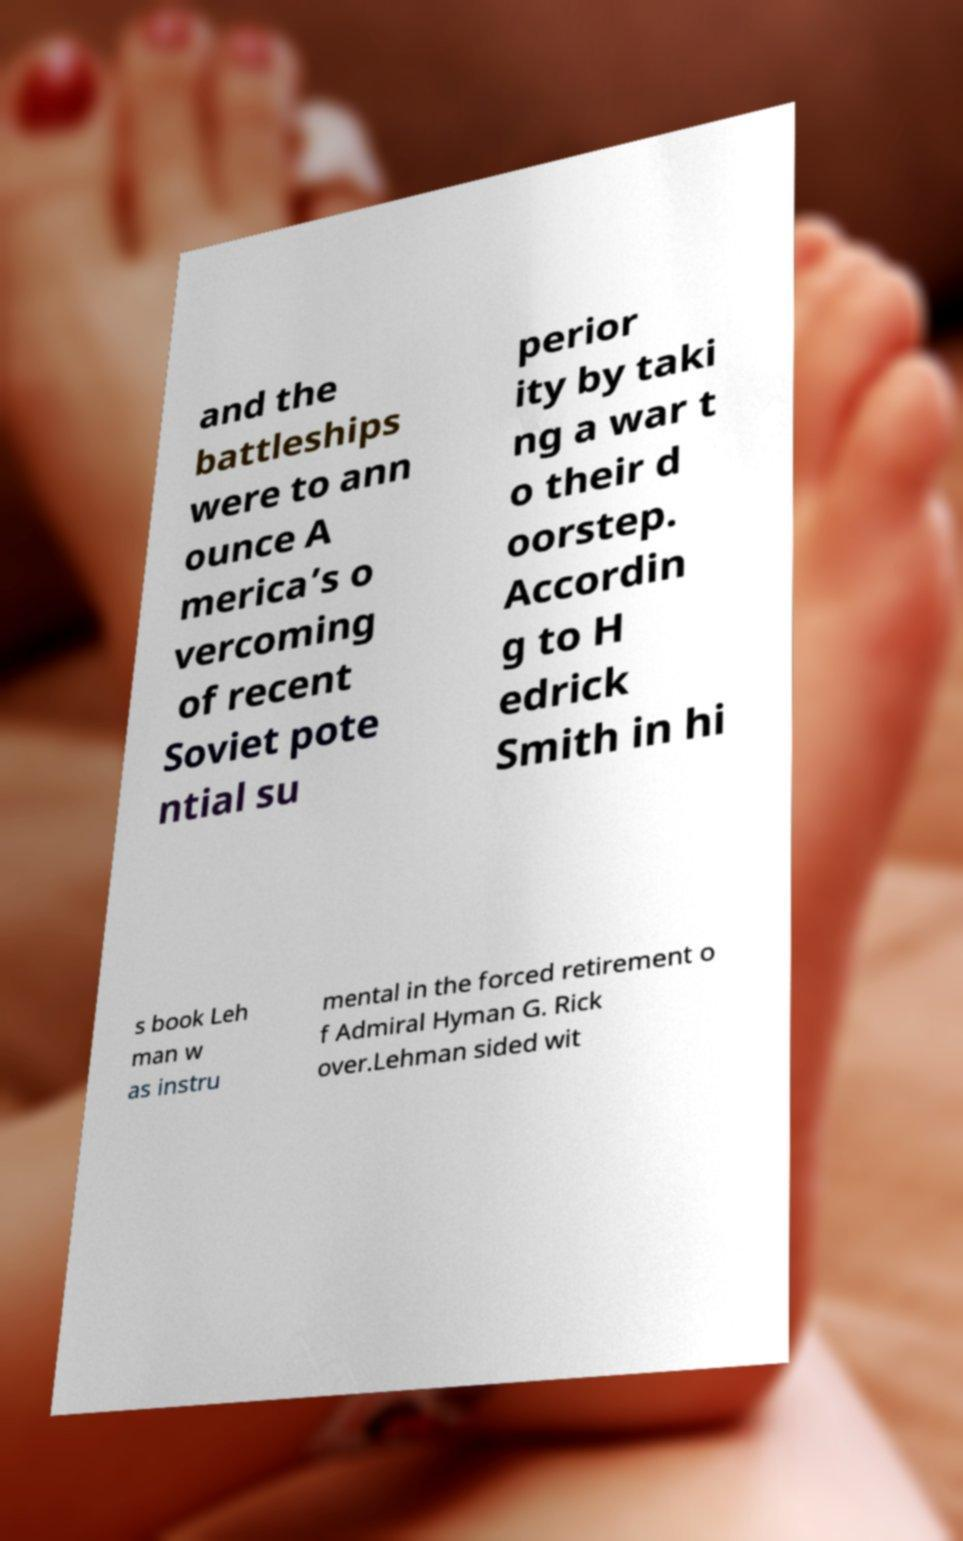Please read and relay the text visible in this image. What does it say? and the battleships were to ann ounce A merica’s o vercoming of recent Soviet pote ntial su perior ity by taki ng a war t o their d oorstep. Accordin g to H edrick Smith in hi s book Leh man w as instru mental in the forced retirement o f Admiral Hyman G. Rick over.Lehman sided wit 